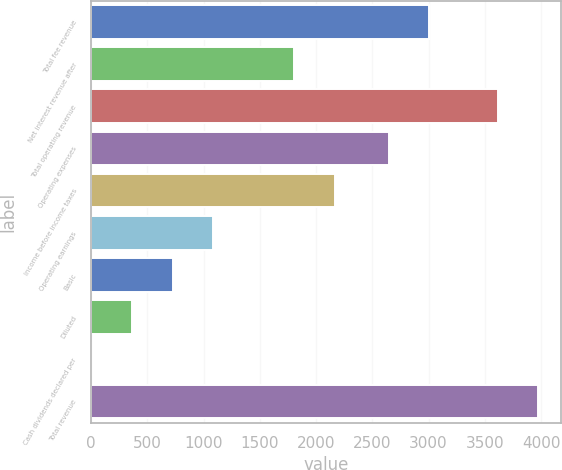Convert chart to OTSL. <chart><loc_0><loc_0><loc_500><loc_500><bar_chart><fcel>Total fee revenue<fcel>Net interest revenue after<fcel>Total operating revenue<fcel>Operating expenses<fcel>Income before income taxes<fcel>Operating earnings<fcel>Basic<fcel>Diluted<fcel>Cash dividends declared per<fcel>Total revenue<nl><fcel>3005.47<fcel>1807.69<fcel>3615<fcel>2644<fcel>2169.16<fcel>1084.75<fcel>723.28<fcel>361.81<fcel>0.34<fcel>3976.47<nl></chart> 